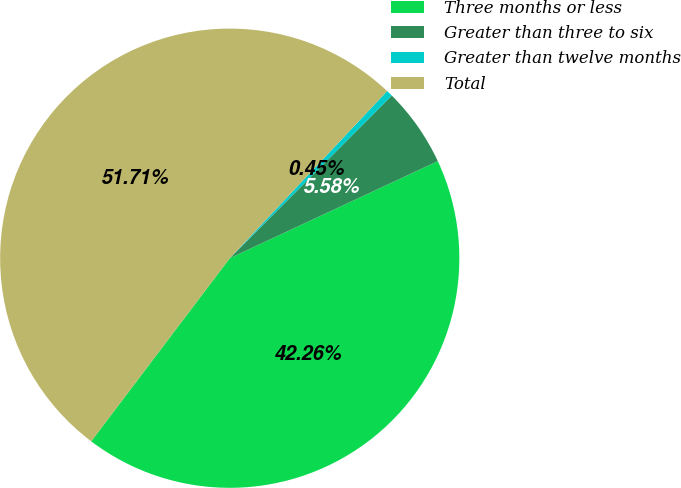Convert chart. <chart><loc_0><loc_0><loc_500><loc_500><pie_chart><fcel>Three months or less<fcel>Greater than three to six<fcel>Greater than twelve months<fcel>Total<nl><fcel>42.26%<fcel>5.58%<fcel>0.45%<fcel>51.71%<nl></chart> 